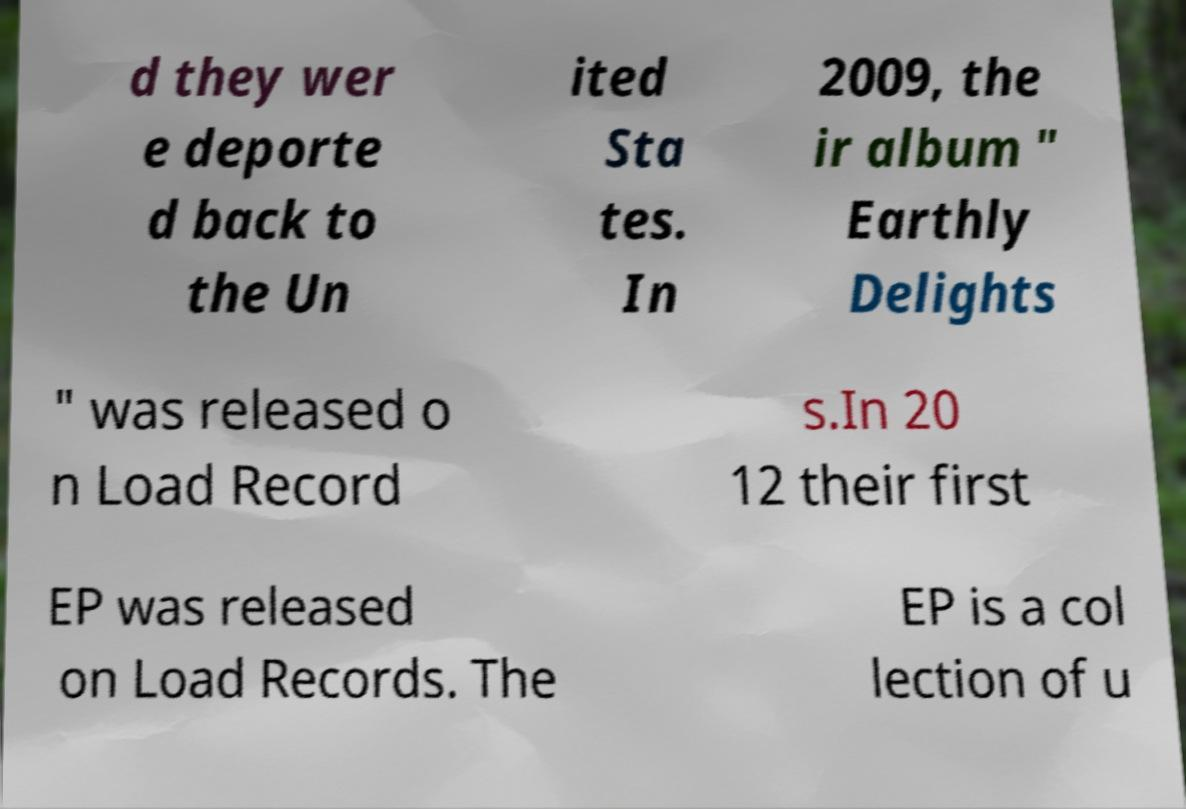Can you accurately transcribe the text from the provided image for me? d they wer e deporte d back to the Un ited Sta tes. In 2009, the ir album " Earthly Delights " was released o n Load Record s.In 20 12 their first EP was released on Load Records. The EP is a col lection of u 